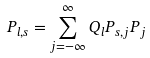<formula> <loc_0><loc_0><loc_500><loc_500>P _ { l , s } = \sum _ { j = - \infty } ^ { \infty } Q _ { l } P _ { s , j } P _ { j }</formula> 